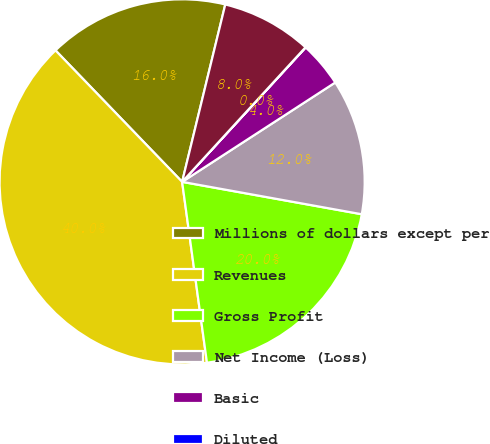<chart> <loc_0><loc_0><loc_500><loc_500><pie_chart><fcel>Millions of dollars except per<fcel>Revenues<fcel>Gross Profit<fcel>Net Income (Loss)<fcel>Basic<fcel>Diluted<fcel>Net Income<nl><fcel>16.0%<fcel>39.97%<fcel>19.99%<fcel>12.0%<fcel>4.01%<fcel>0.02%<fcel>8.01%<nl></chart> 